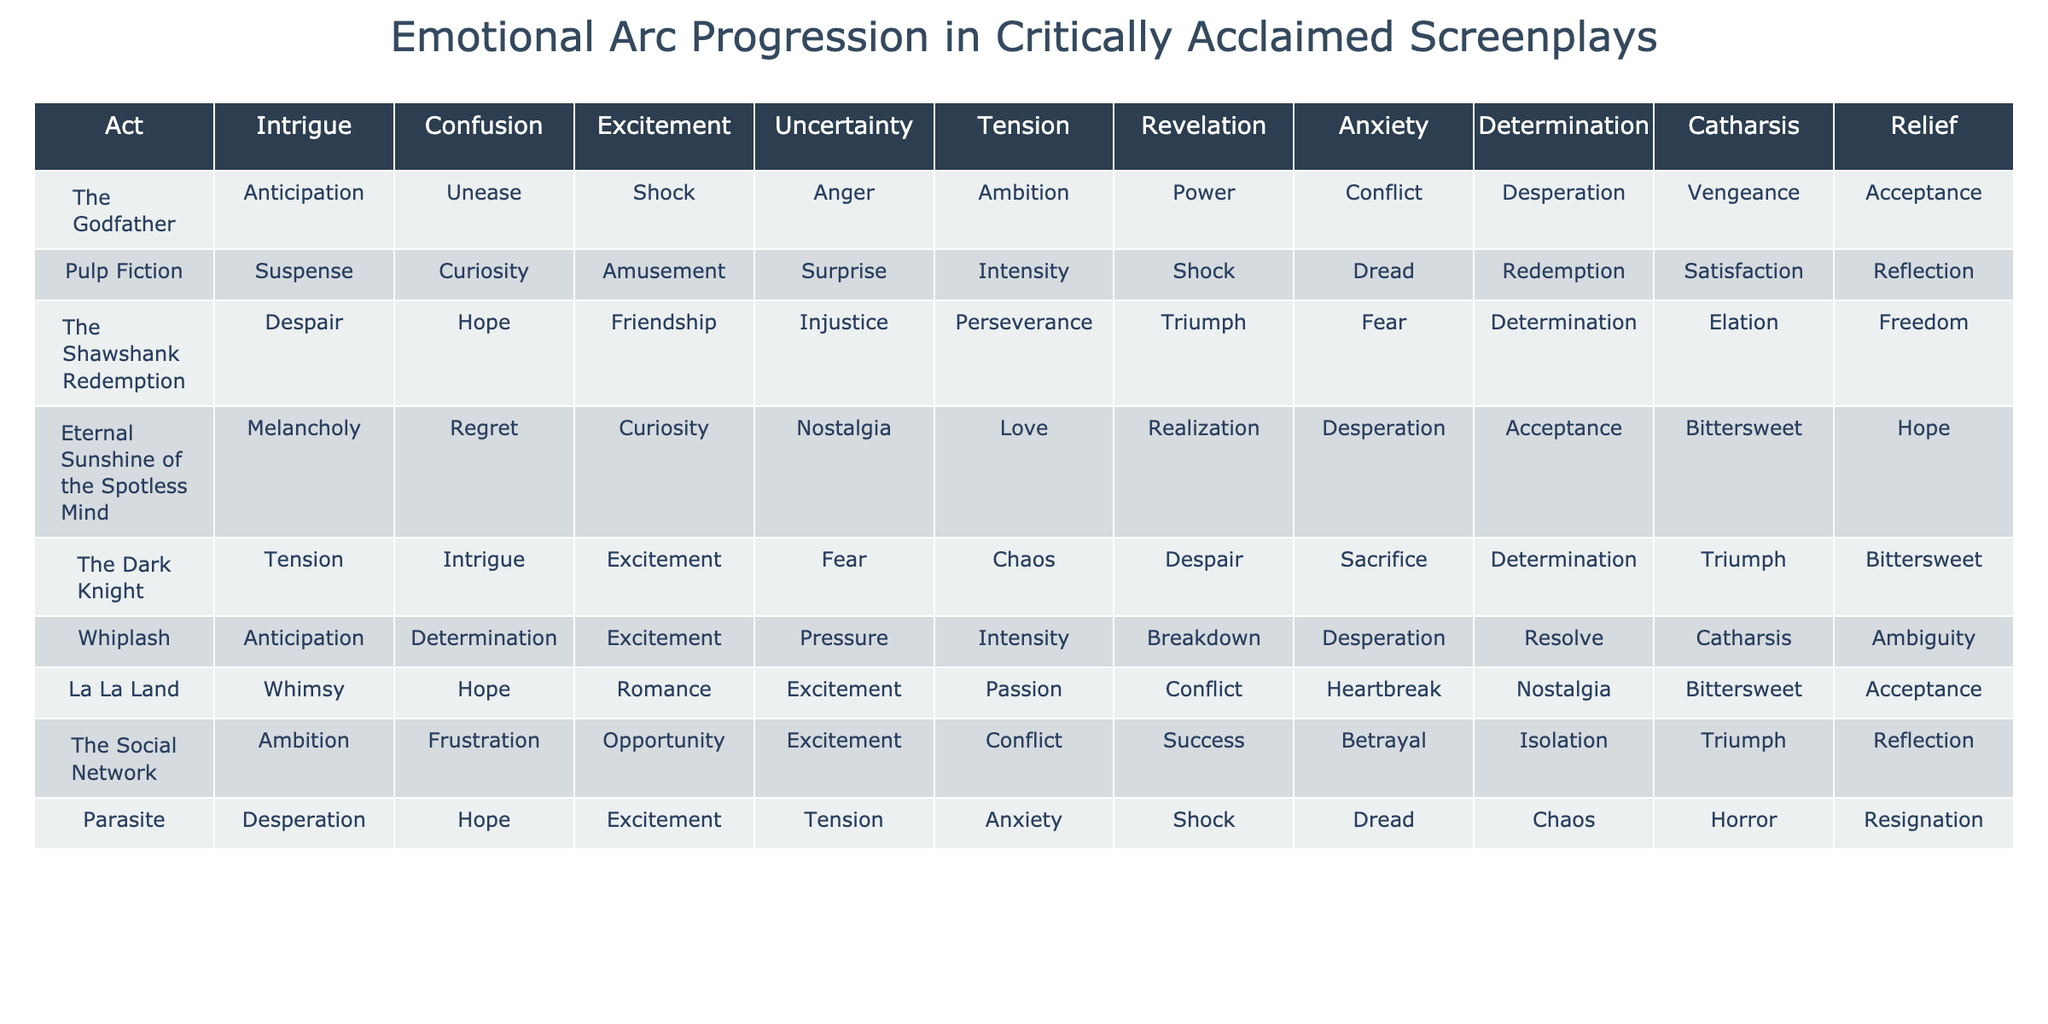What is the emotional response at the Midpoint in "Pulp Fiction"? The table indicates that the emotional response at the Midpoint for "Pulp Fiction" is labeled as "Shock".
Answer: Shock Which screenplay has the highest emotional tension at the Second Plot Point? Looking at the table, "Parasite" shows the highest emotional tension at the Second Plot Point with the response "Chaos".
Answer: Chaos Is there any screenplay that has a "Determination" response at both the First Plot Point and the Climax? By examining the data, "Inception" is the only screenplay that features a "Determination" response at both those points.
Answer: Yes Which screenplay exhibits a predominant emotional arc of "Desperation" at the Opening and under what emotional state does it culminate? "Parasite" starts with "Desperation" at the Opening and culminates in "Resignation" at the Resolution, showing a downward emotional trajectory.
Answer: Resignation Which emotional arc descends from the Midpoint to the Climax in "The Dark Knight"? In "The Dark Knight", the emotional arc descends from "Despair" at the Midpoint to "Triumph" at the Climax, indicating an overcoming of challenges.
Answer: Triumph What is the common emotional thread present throughout "The Shawshank Redemption"? The emotional thread in "The Shawshank Redemption" starts with "Despair" and gradually transitions through "Hope", "Friendship", and culminates in "Freedom", showing growth.
Answer: Freedom How many screenplays reach a state of "Acceptance" at the Resolution? By analyzing the table, "Eternal Sunshine of the Spotless Mind", "La La Land", and "The Godfather" all arrive at "Acceptance" at the Resolution, totaling three.
Answer: Three What emotional response does "Whiplash" show during its Rising Action and how does it relate to the overall arc? "Whiplash" shows "Intensity" during its Rising Action, contributing to a tumultuous emotional experience that leads to its climactic breakdown.
Answer: Intensity Which screenplay transitions from "Unease" to "Acceptance"? "The Godfather" transitions from an emotional state of "Unease" at the Setup to "Acceptance" at the Resolution, illustrating an arc of resolution.
Answer: The Godfather What is the overall emotional peak (highest intensity) of "Inception" and at what point does it occur? "Inception" peaks emotionally at the Climax with "Catharsis", indicating a significant release of tension at that critical point.
Answer: Catharsis 